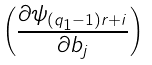Convert formula to latex. <formula><loc_0><loc_0><loc_500><loc_500>\begin{pmatrix} \frac { \partial \psi _ { ( q _ { 1 } - 1 ) r + i } } { \partial b _ { j } } \end{pmatrix}</formula> 